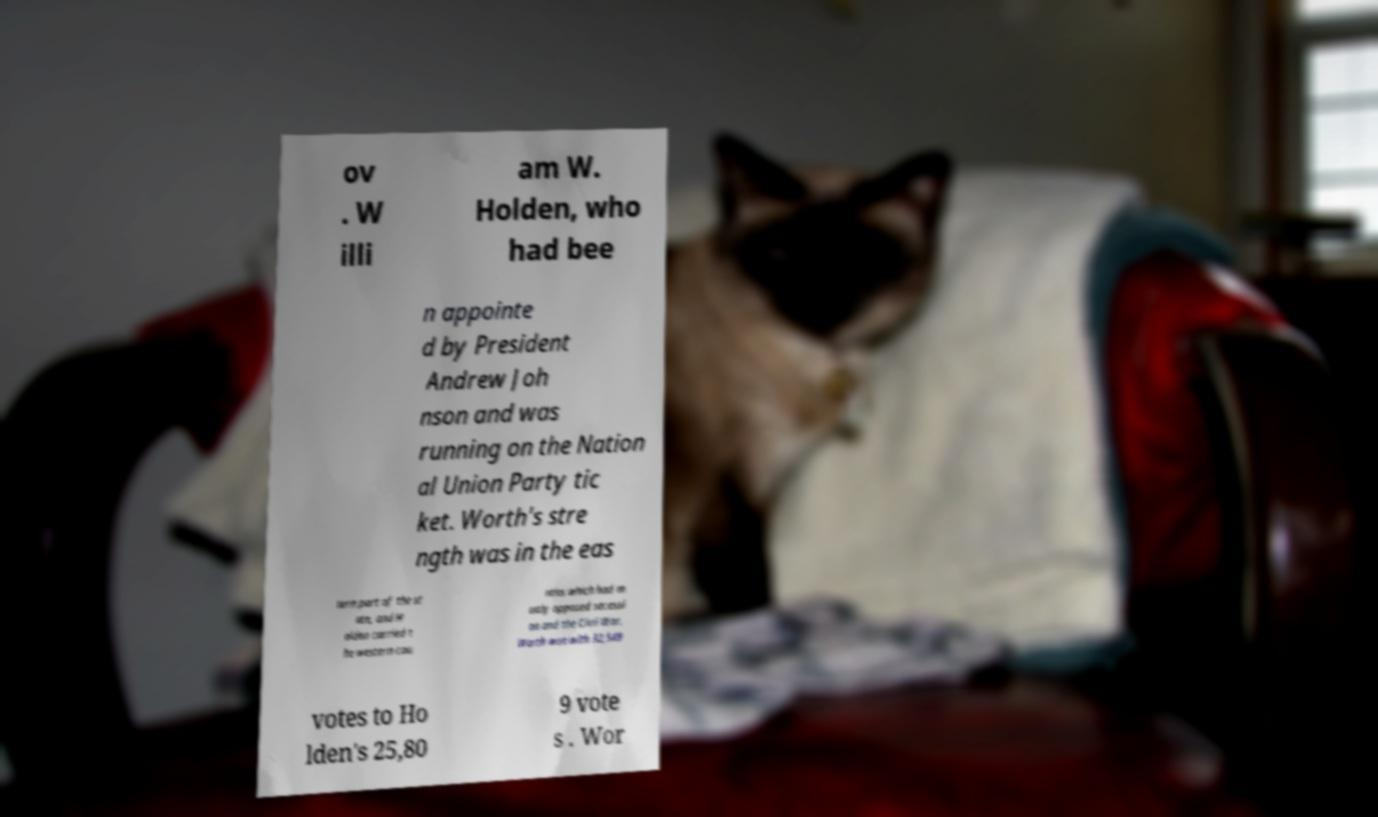Can you accurately transcribe the text from the provided image for me? ov . W illi am W. Holden, who had bee n appointe d by President Andrew Joh nson and was running on the Nation al Union Party tic ket. Worth's stre ngth was in the eas tern part of the st ate, and H olden carried t he western cou nties which had m ostly opposed secessi on and the Civil War. Worth won with 32,549 votes to Ho lden's 25,80 9 vote s . Wor 